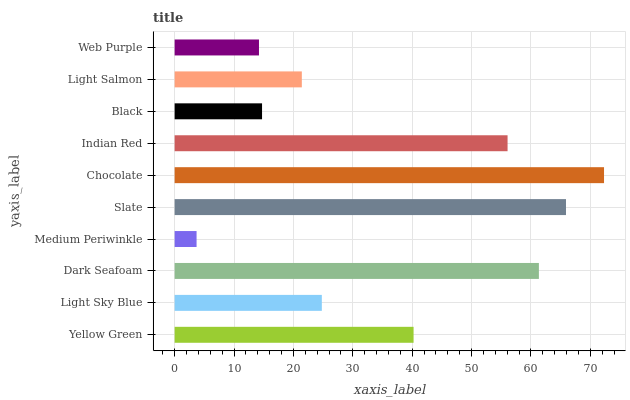Is Medium Periwinkle the minimum?
Answer yes or no. Yes. Is Chocolate the maximum?
Answer yes or no. Yes. Is Light Sky Blue the minimum?
Answer yes or no. No. Is Light Sky Blue the maximum?
Answer yes or no. No. Is Yellow Green greater than Light Sky Blue?
Answer yes or no. Yes. Is Light Sky Blue less than Yellow Green?
Answer yes or no. Yes. Is Light Sky Blue greater than Yellow Green?
Answer yes or no. No. Is Yellow Green less than Light Sky Blue?
Answer yes or no. No. Is Yellow Green the high median?
Answer yes or no. Yes. Is Light Sky Blue the low median?
Answer yes or no. Yes. Is Slate the high median?
Answer yes or no. No. Is Light Salmon the low median?
Answer yes or no. No. 